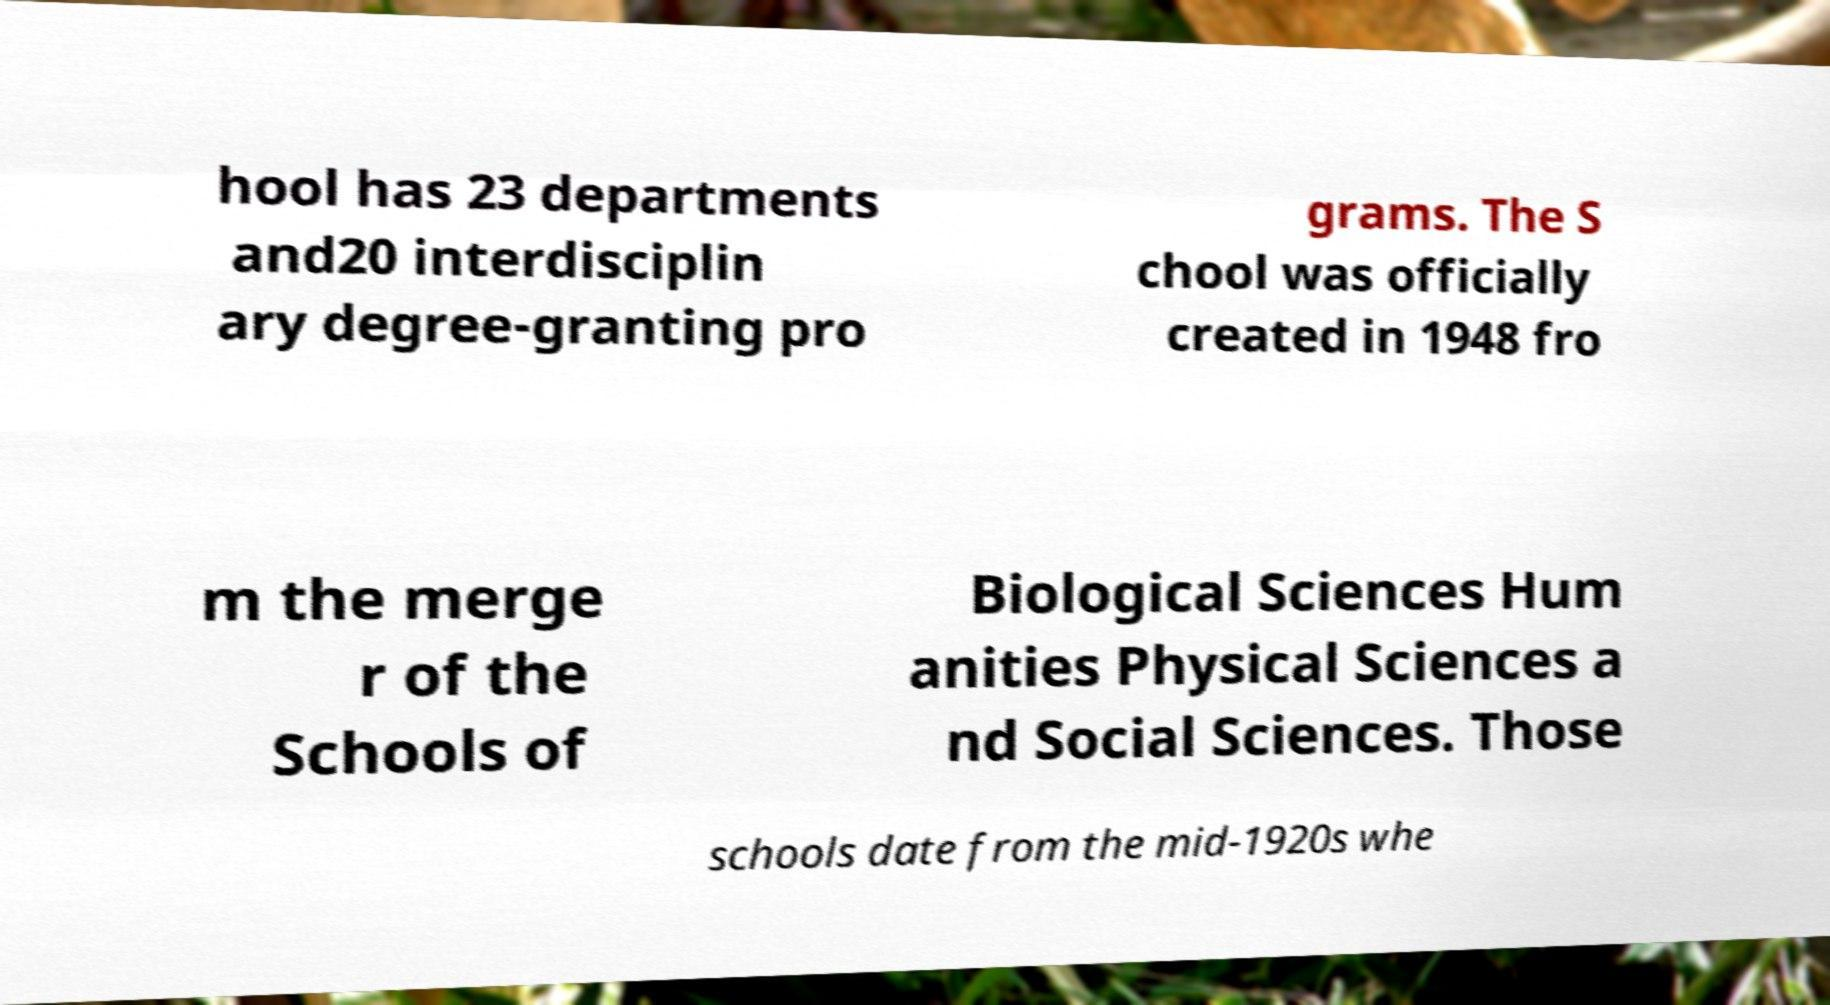I need the written content from this picture converted into text. Can you do that? hool has 23 departments and20 interdisciplin ary degree-granting pro grams. The S chool was officially created in 1948 fro m the merge r of the Schools of Biological Sciences Hum anities Physical Sciences a nd Social Sciences. Those schools date from the mid-1920s whe 